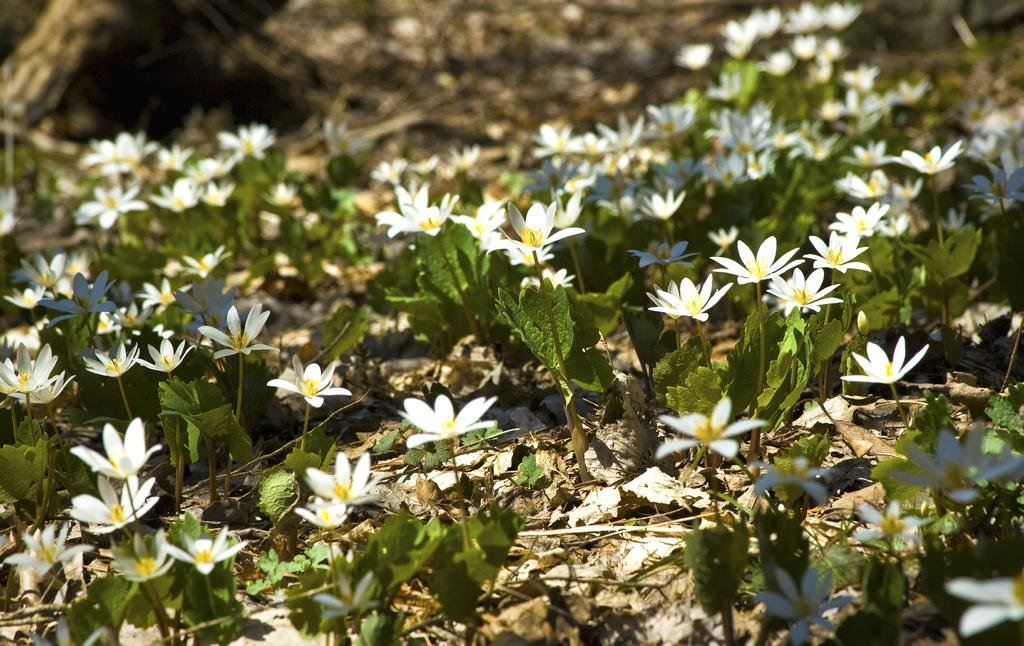What type of plants can be seen in the image? There are white color flower plants in the image. What can be found on the ground in the image? Dry leaves are present on the land in the image. Where is the bark of a tree located in the image? The bark of a tree is in the left top of the image. Is there a bear smoking a loaf of bread in the image? No, there is no bear or smoking loaf of bread present in the image. 